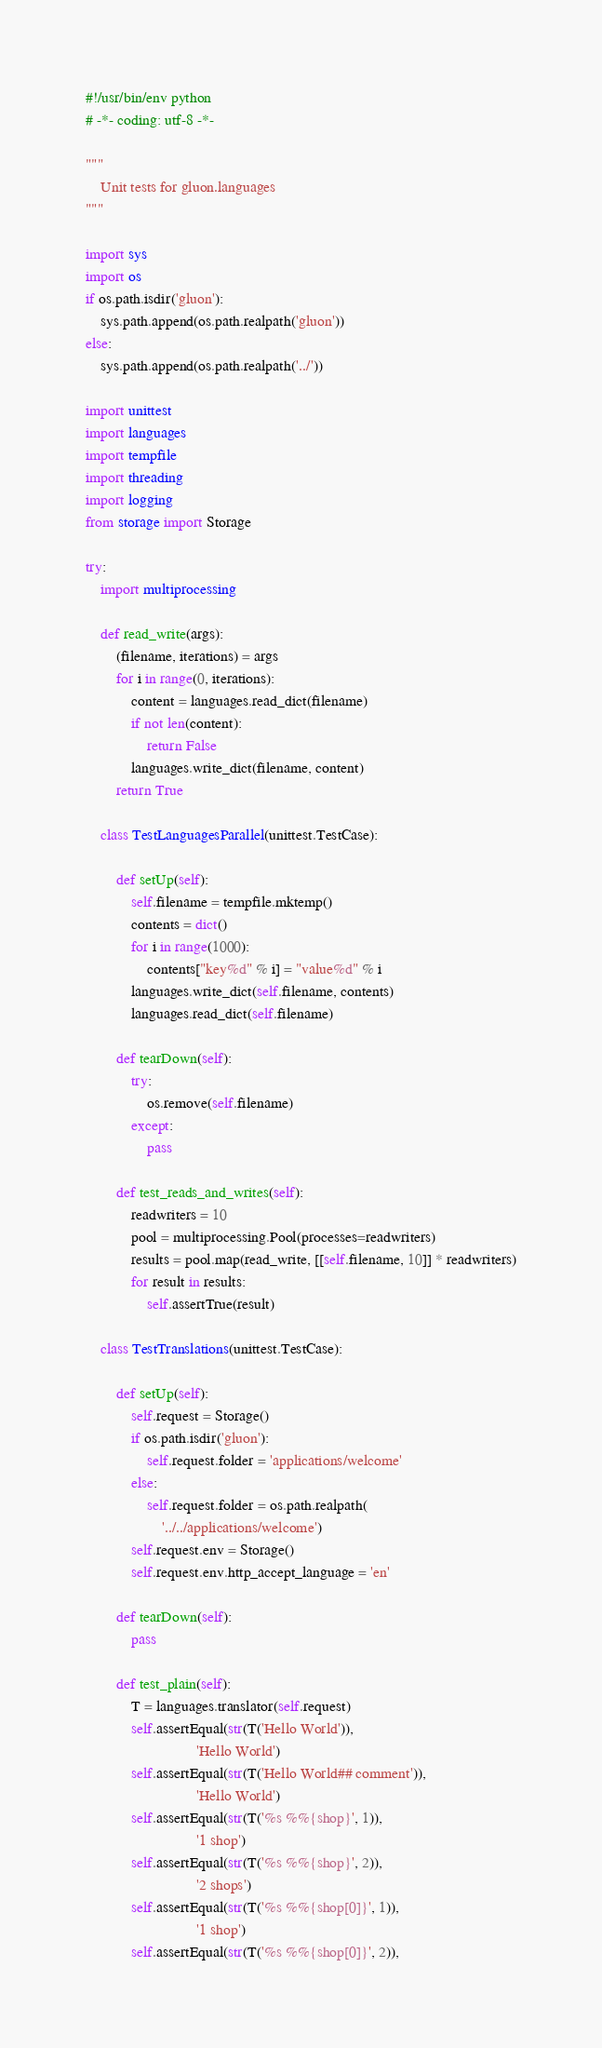Convert code to text. <code><loc_0><loc_0><loc_500><loc_500><_Python_>#!/usr/bin/env python
# -*- coding: utf-8 -*-

"""
    Unit tests for gluon.languages
"""

import sys
import os
if os.path.isdir('gluon'):
    sys.path.append(os.path.realpath('gluon'))
else:
    sys.path.append(os.path.realpath('../'))

import unittest
import languages
import tempfile
import threading
import logging
from storage import Storage

try:
    import multiprocessing

    def read_write(args):
        (filename, iterations) = args
        for i in range(0, iterations):
            content = languages.read_dict(filename)
            if not len(content):
                return False
            languages.write_dict(filename, content)
        return True

    class TestLanguagesParallel(unittest.TestCase):

        def setUp(self):
            self.filename = tempfile.mktemp()
            contents = dict()
            for i in range(1000):
                contents["key%d" % i] = "value%d" % i
            languages.write_dict(self.filename, contents)
            languages.read_dict(self.filename)

        def tearDown(self):
            try:
                os.remove(self.filename)
            except:
                pass

        def test_reads_and_writes(self):
            readwriters = 10
            pool = multiprocessing.Pool(processes=readwriters)
            results = pool.map(read_write, [[self.filename, 10]] * readwriters)
            for result in results:
                self.assertTrue(result)

    class TestTranslations(unittest.TestCase):

        def setUp(self):
            self.request = Storage()
            if os.path.isdir('gluon'):
                self.request.folder = 'applications/welcome'
            else:
                self.request.folder = os.path.realpath(
                    '../../applications/welcome')
            self.request.env = Storage()
            self.request.env.http_accept_language = 'en'

        def tearDown(self):
            pass

        def test_plain(self):
            T = languages.translator(self.request)
            self.assertEqual(str(T('Hello World')),
                             'Hello World')
            self.assertEqual(str(T('Hello World## comment')),
                             'Hello World')
            self.assertEqual(str(T('%s %%{shop}', 1)),
                             '1 shop')
            self.assertEqual(str(T('%s %%{shop}', 2)),
                             '2 shops')
            self.assertEqual(str(T('%s %%{shop[0]}', 1)),
                             '1 shop')
            self.assertEqual(str(T('%s %%{shop[0]}', 2)),</code> 